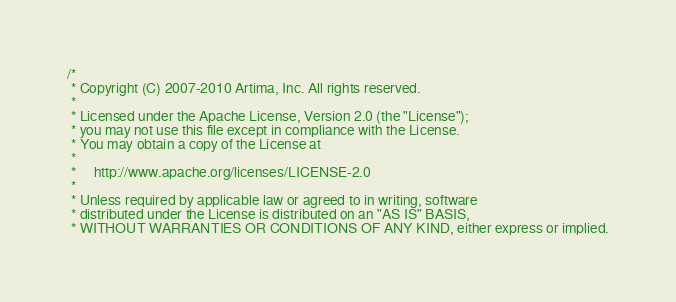Convert code to text. <code><loc_0><loc_0><loc_500><loc_500><_Scala_>/*
 * Copyright (C) 2007-2010 Artima, Inc. All rights reserved.
 * 
 * Licensed under the Apache License, Version 2.0 (the "License");
 * you may not use this file except in compliance with the License.
 * You may obtain a copy of the License at
 * 
 *     http://www.apache.org/licenses/LICENSE-2.0
 * 
 * Unless required by applicable law or agreed to in writing, software
 * distributed under the License is distributed on an "AS IS" BASIS,
 * WITHOUT WARRANTIES OR CONDITIONS OF ANY KIND, either express or implied.</code> 